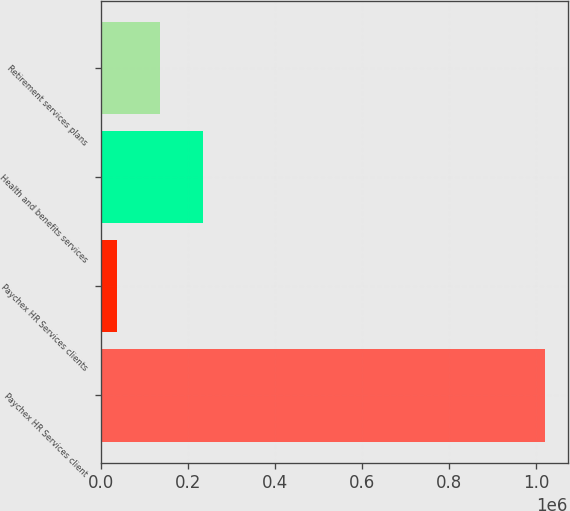Convert chart. <chart><loc_0><loc_0><loc_500><loc_500><bar_chart><fcel>Paychex HR Services client<fcel>Paychex HR Services clients<fcel>Health and benefits services<fcel>Retirement services plans<nl><fcel>1.021e+06<fcel>37000<fcel>233800<fcel>135400<nl></chart> 